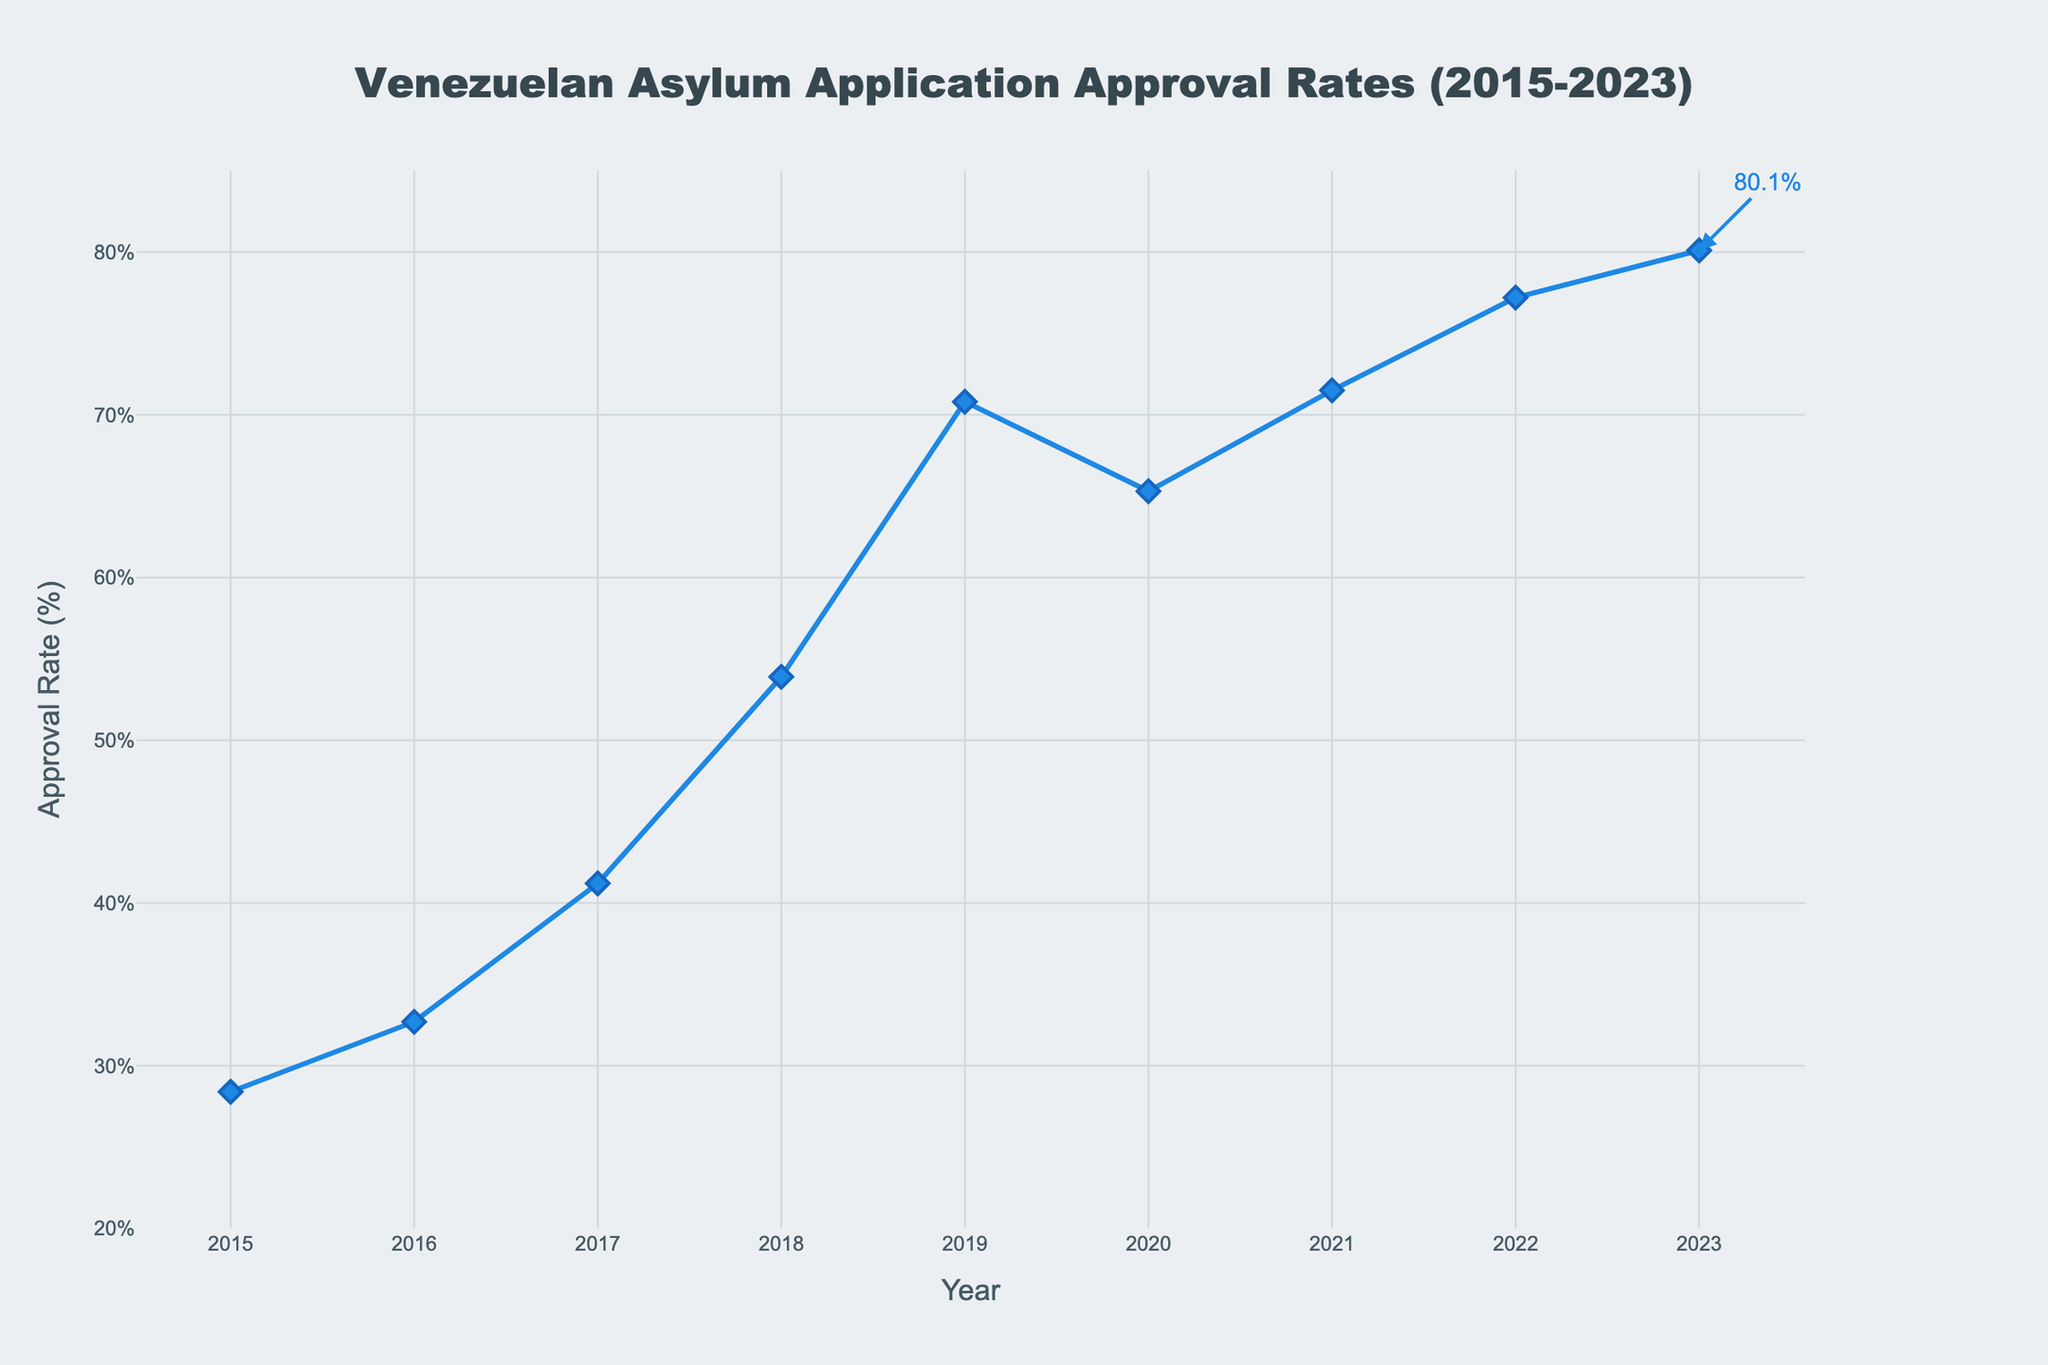What is the approval rate for 2020? Look at the figure and find the point corresponding to the year 2020. The label shows the approval rate at that point.
Answer: 65.3% How does the approval rate in 2023 compare to 2015? Compare the approval rates for 2023 (80.1%) and 2015 (28.4%) as indicated on the y-axis for these corresponding years.
Answer: 2023 is higher What was the percentage increase in approval rate from 2015 to 2023? Calculate the difference between the approval rates in 2023 and 2015 (80.1% - 28.4%) and then divide by 28.4% and multiply by 100 to get the percentage increase.
Answer: 181.7% Which year saw the highest approval rate? Determine the highest point on the y-axis and find the corresponding year on the x-axis.
Answer: 2023 In which year(s) did the approval rate decrease compared to the previous year? Look at the slope between consecutive points on the line chart. A downward slope indicates a decrease. Find the relevant year(s).
Answer: 2020 What is the average approval rate from 2015 to 2019? Sum the approval rates from 2015 to 2019 (28.4 + 32.7 + 41.2 + 53.9 + 70.8) and divide by 5.
Answer: 45.4% Between which consecutive years was the largest increase in approval rates observed? Check the differences in approval rates between consecutive years and identify the largest one. Calculate for each pair and compare, for instance: (53.9 - 41.2) from 2017 to 2018, versus (70.8 - 53.9) from 2018 to 2019, etc.
Answer: 2018 to 2019 What trend is observed in the approval rates from 2018 to 2023? Analyze the points from 2018 to 2023 and observe if they are increasing, decreasing, or staying the same.
Answer: Increasing How many years show an approval rate above 50%? Count the number of points above the 50% mark on the y-axis.
Answer: 6 What is the combined approval rate for the years 2022 and 2023? Sum the approval rates for 2022 and 2023 (77.2% + 80.1%).
Answer: 157.3% 